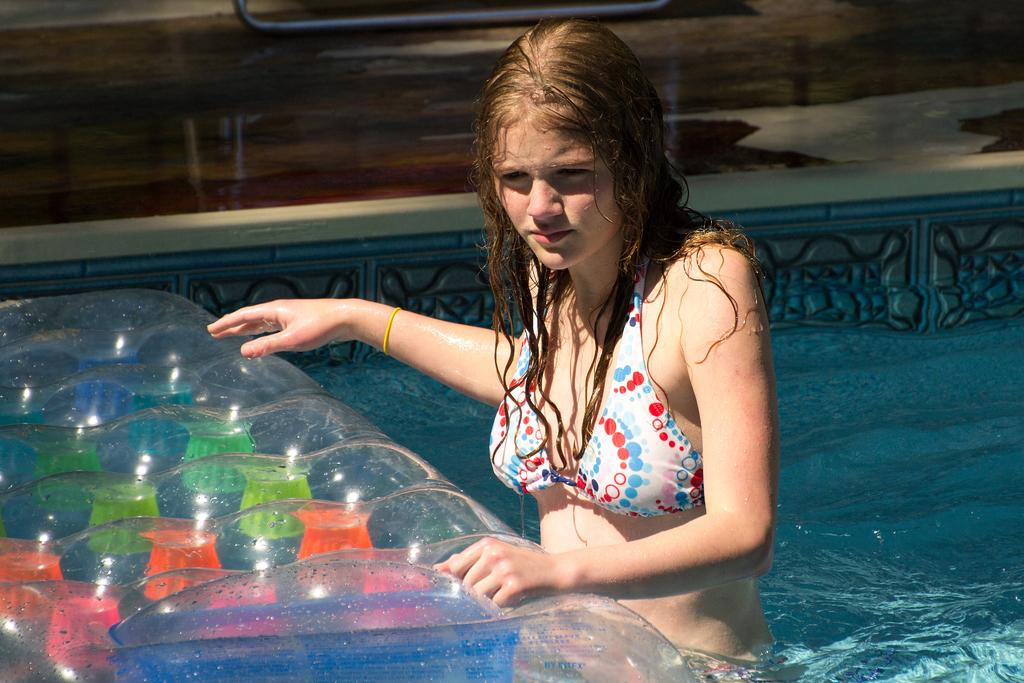What is the person in the image doing? The person is in the water in the image. What object is in front of the person? There is a float in front of the person. What can be seen in the background of the image? There is a floor visible in the background of the image. What scent is the ant emitting in the image? There is no ant present in the image, so it is not possible to determine any scent. 